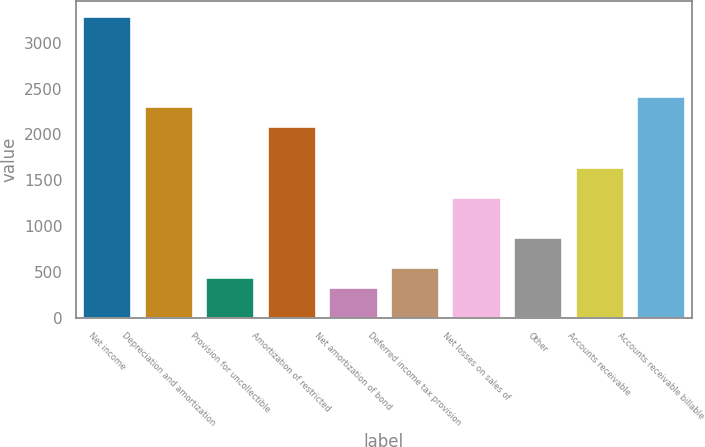<chart> <loc_0><loc_0><loc_500><loc_500><bar_chart><fcel>Net income<fcel>Depreciation and amortization<fcel>Provision for uncollectible<fcel>Amortization of restricted<fcel>Net amortization of bond<fcel>Deferred income tax provision<fcel>Net losses on sales of<fcel>Other<fcel>Accounts receivable<fcel>Accounts receivable billable<nl><fcel>3297.43<fcel>2308.69<fcel>441.07<fcel>2088.97<fcel>331.21<fcel>550.93<fcel>1319.95<fcel>880.51<fcel>1649.53<fcel>2418.55<nl></chart> 